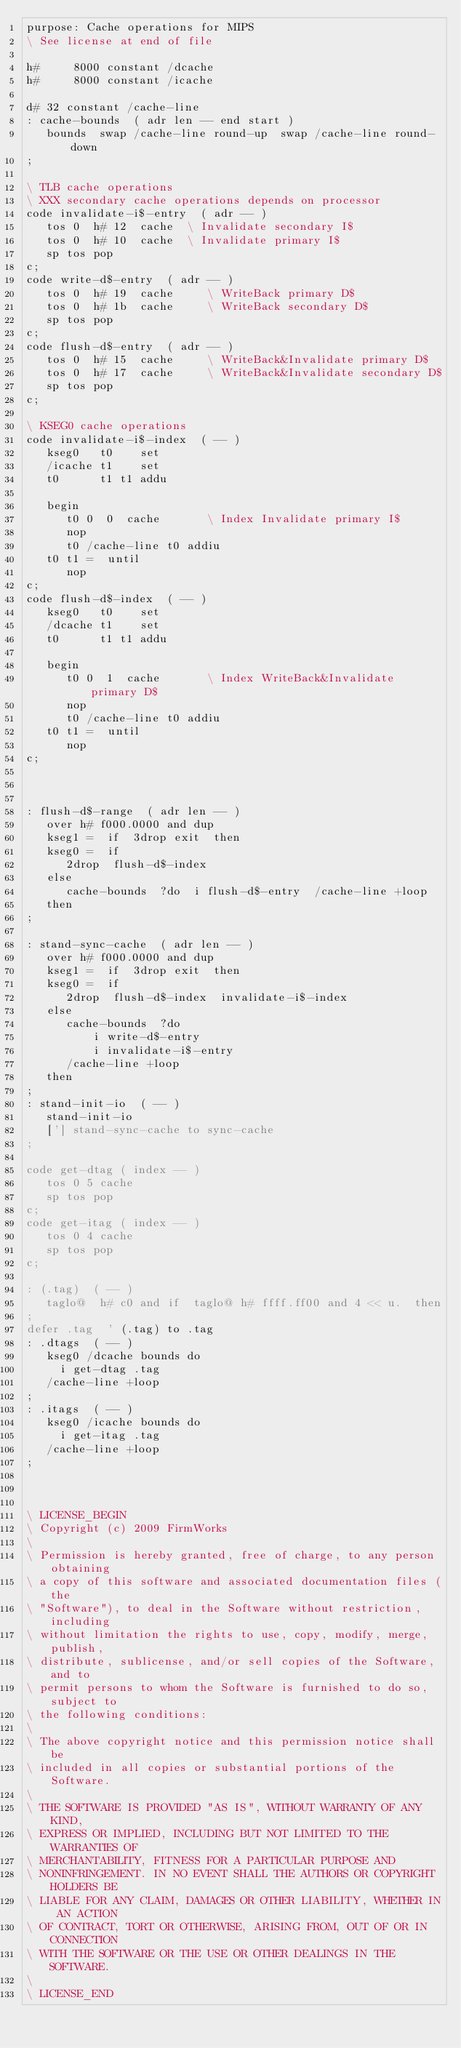<code> <loc_0><loc_0><loc_500><loc_500><_Forth_>purpose: Cache operations for MIPS
\ See license at end of file

h#     8000 constant /dcache
h#     8000 constant /icache

d# 32 constant /cache-line
: cache-bounds  ( adr len -- end start )
   bounds  swap /cache-line round-up  swap /cache-line round-down
;

\ TLB cache operations
\ XXX secondary cache operations depends on processor
code invalidate-i$-entry  ( adr -- )
   tos 0  h# 12  cache	\ Invalidate secondary I$
   tos 0  h# 10  cache	\ Invalidate primary I$
   sp tos pop
c;
code write-d$-entry  ( adr -- )
   tos 0  h# 19  cache     \ WriteBack primary D$
   tos 0  h# 1b  cache     \ WriteBack secondary D$
   sp tos pop
c;
code flush-d$-entry  ( adr -- )
   tos 0  h# 15  cache     \ WriteBack&Invalidate primary D$
   tos 0  h# 17  cache     \ WriteBack&Invalidate secondary D$
   sp tos pop
c;

\ KSEG0 cache operations
code invalidate-i$-index  ( -- )
   kseg0   t0    set
   /icache t1    set
   t0      t1 t1 addu

   begin
      t0 0  0  cache	   \ Index Invalidate primary I$
      nop
      t0 /cache-line t0 addiu
   t0 t1 =  until
      nop
c;
code flush-d$-index  ( -- )
   kseg0   t0    set
   /dcache t1    set
   t0      t1 t1 addu

   begin
      t0 0  1  cache	   \ Index WriteBack&Invalidate primary D$
      nop
      t0 /cache-line t0 addiu
   t0 t1 =  until
      nop
c;



: flush-d$-range  ( adr len -- )
   over h# f000.0000 and dup
   kseg1 =  if  3drop exit  then
   kseg0 =  if
      2drop  flush-d$-index
   else
      cache-bounds  ?do  i flush-d$-entry  /cache-line +loop
   then
;

: stand-sync-cache  ( adr len -- )
   over h# f000.0000 and dup
   kseg1 =  if  3drop exit  then
   kseg0 =  if
      2drop  flush-d$-index  invalidate-i$-index
   else
      cache-bounds  ?do
          i write-d$-entry
          i invalidate-i$-entry
      /cache-line +loop
   then
;
: stand-init-io  ( -- )
   stand-init-io
   ['] stand-sync-cache to sync-cache
;

code get-dtag ( index -- )
   tos 0 5 cache
   sp tos pop
c;
code get-itag ( index -- )
   tos 0 4 cache
   sp tos pop
c;

: (.tag)  ( -- )
   taglo@  h# c0 and if  taglo@ h# ffff.ff00 and 4 << u.  then
;
defer .tag  ' (.tag) to .tag
: .dtags  ( -- )
   kseg0 /dcache bounds do
     i get-dtag .tag
   /cache-line +loop
;
: .itags  ( -- )
   kseg0 /icache bounds do
     i get-itag .tag
   /cache-line +loop
;



\ LICENSE_BEGIN
\ Copyright (c) 2009 FirmWorks
\ 
\ Permission is hereby granted, free of charge, to any person obtaining
\ a copy of this software and associated documentation files (the
\ "Software"), to deal in the Software without restriction, including
\ without limitation the rights to use, copy, modify, merge, publish,
\ distribute, sublicense, and/or sell copies of the Software, and to
\ permit persons to whom the Software is furnished to do so, subject to
\ the following conditions:
\ 
\ The above copyright notice and this permission notice shall be
\ included in all copies or substantial portions of the Software.
\ 
\ THE SOFTWARE IS PROVIDED "AS IS", WITHOUT WARRANTY OF ANY KIND,
\ EXPRESS OR IMPLIED, INCLUDING BUT NOT LIMITED TO THE WARRANTIES OF
\ MERCHANTABILITY, FITNESS FOR A PARTICULAR PURPOSE AND
\ NONINFRINGEMENT. IN NO EVENT SHALL THE AUTHORS OR COPYRIGHT HOLDERS BE
\ LIABLE FOR ANY CLAIM, DAMAGES OR OTHER LIABILITY, WHETHER IN AN ACTION
\ OF CONTRACT, TORT OR OTHERWISE, ARISING FROM, OUT OF OR IN CONNECTION
\ WITH THE SOFTWARE OR THE USE OR OTHER DEALINGS IN THE SOFTWARE.
\
\ LICENSE_END
</code> 